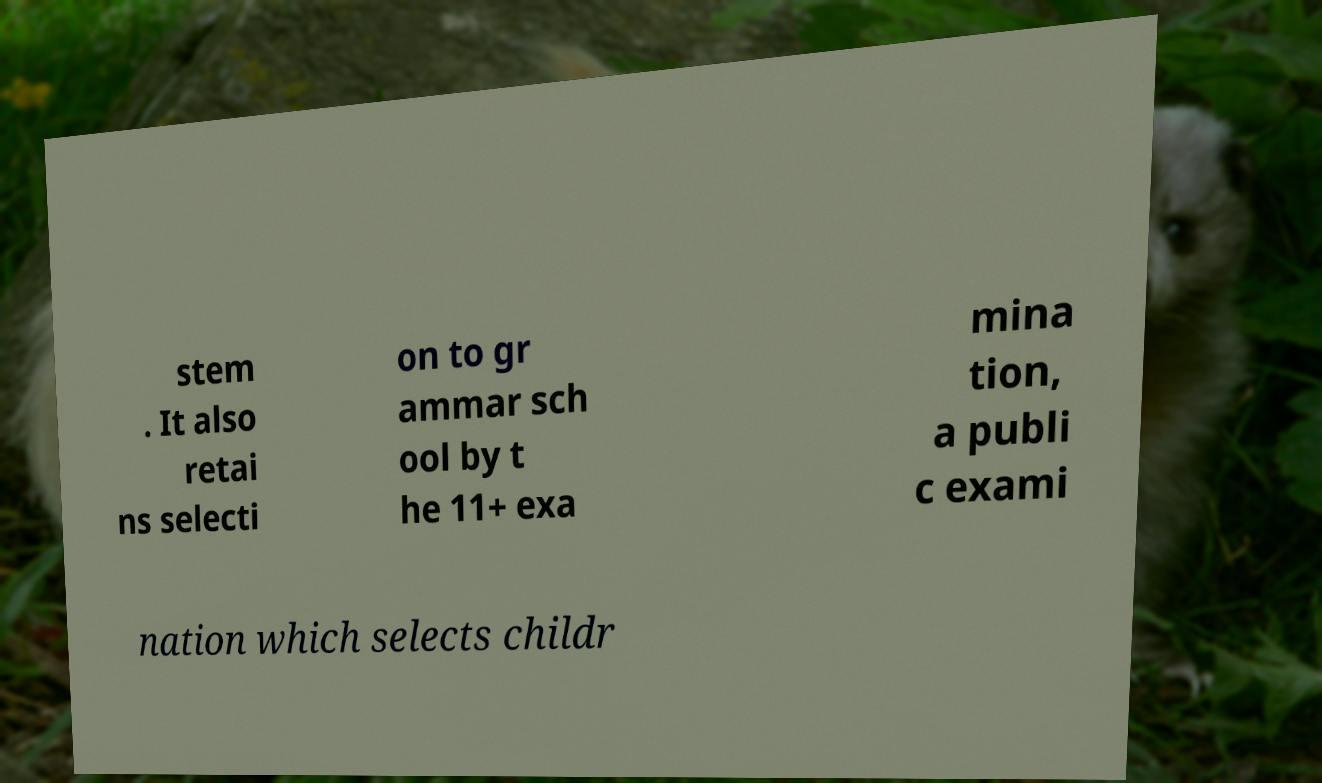Could you extract and type out the text from this image? stem . It also retai ns selecti on to gr ammar sch ool by t he 11+ exa mina tion, a publi c exami nation which selects childr 